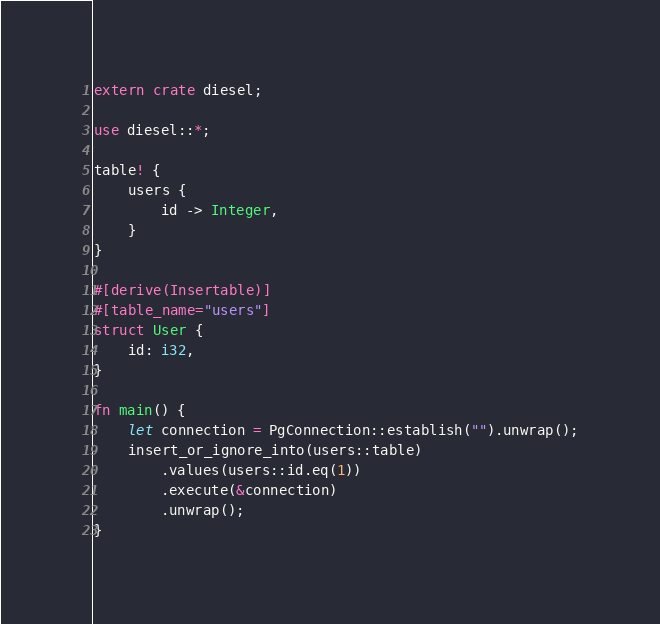Convert code to text. <code><loc_0><loc_0><loc_500><loc_500><_Rust_>extern crate diesel;

use diesel::*;

table! {
    users {
        id -> Integer,
    }
}

#[derive(Insertable)]
#[table_name="users"]
struct User {
    id: i32,
}

fn main() {
    let connection = PgConnection::establish("").unwrap();
    insert_or_ignore_into(users::table)
        .values(users::id.eq(1))
        .execute(&connection)
        .unwrap();
}
</code> 